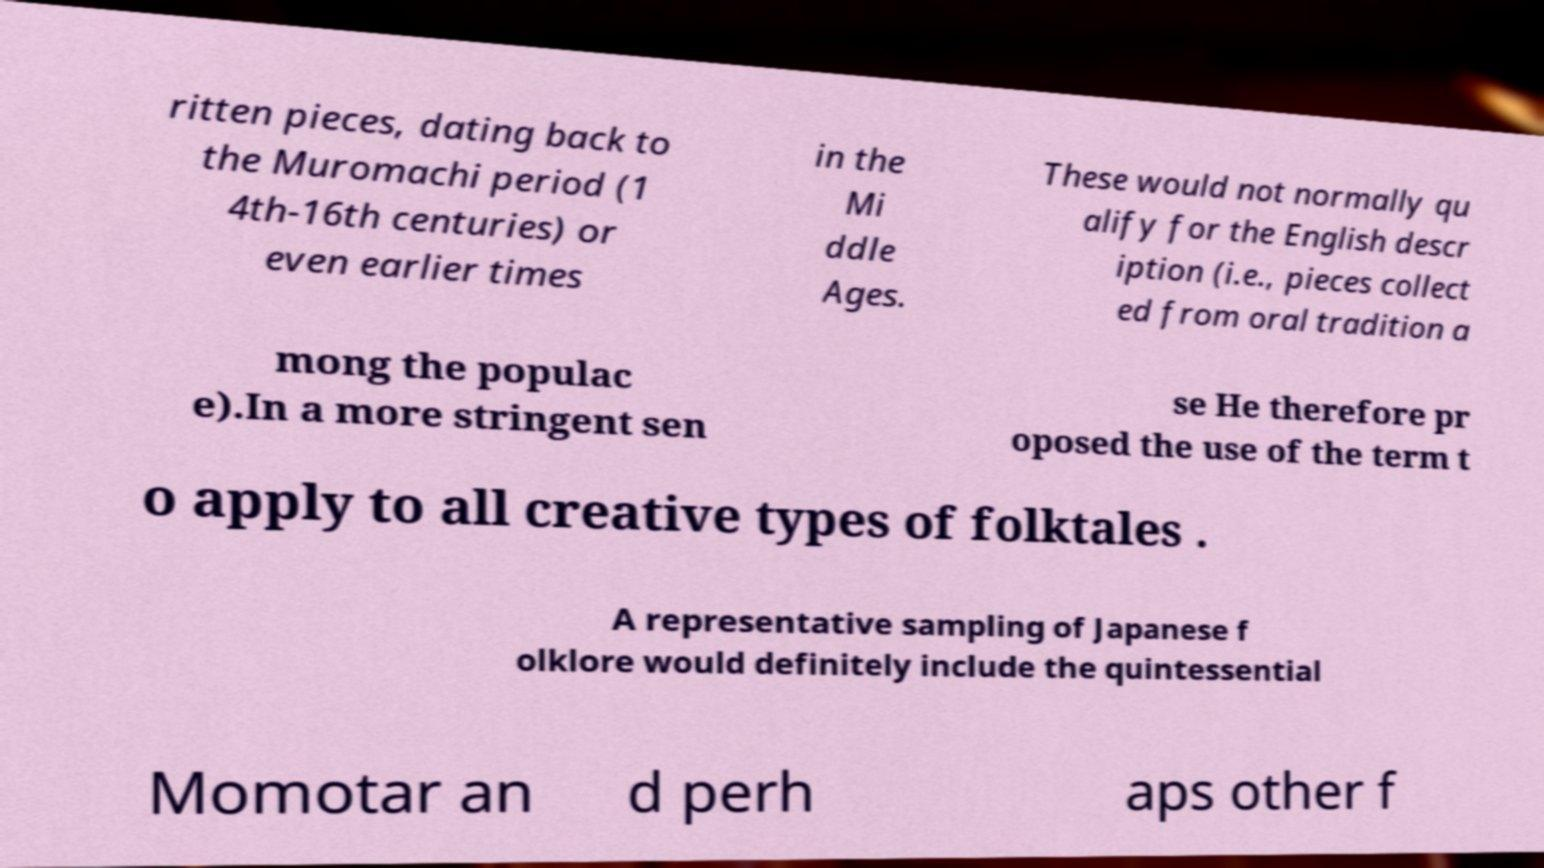Please read and relay the text visible in this image. What does it say? ritten pieces, dating back to the Muromachi period (1 4th-16th centuries) or even earlier times in the Mi ddle Ages. These would not normally qu alify for the English descr iption (i.e., pieces collect ed from oral tradition a mong the populac e).In a more stringent sen se He therefore pr oposed the use of the term t o apply to all creative types of folktales . A representative sampling of Japanese f olklore would definitely include the quintessential Momotar an d perh aps other f 